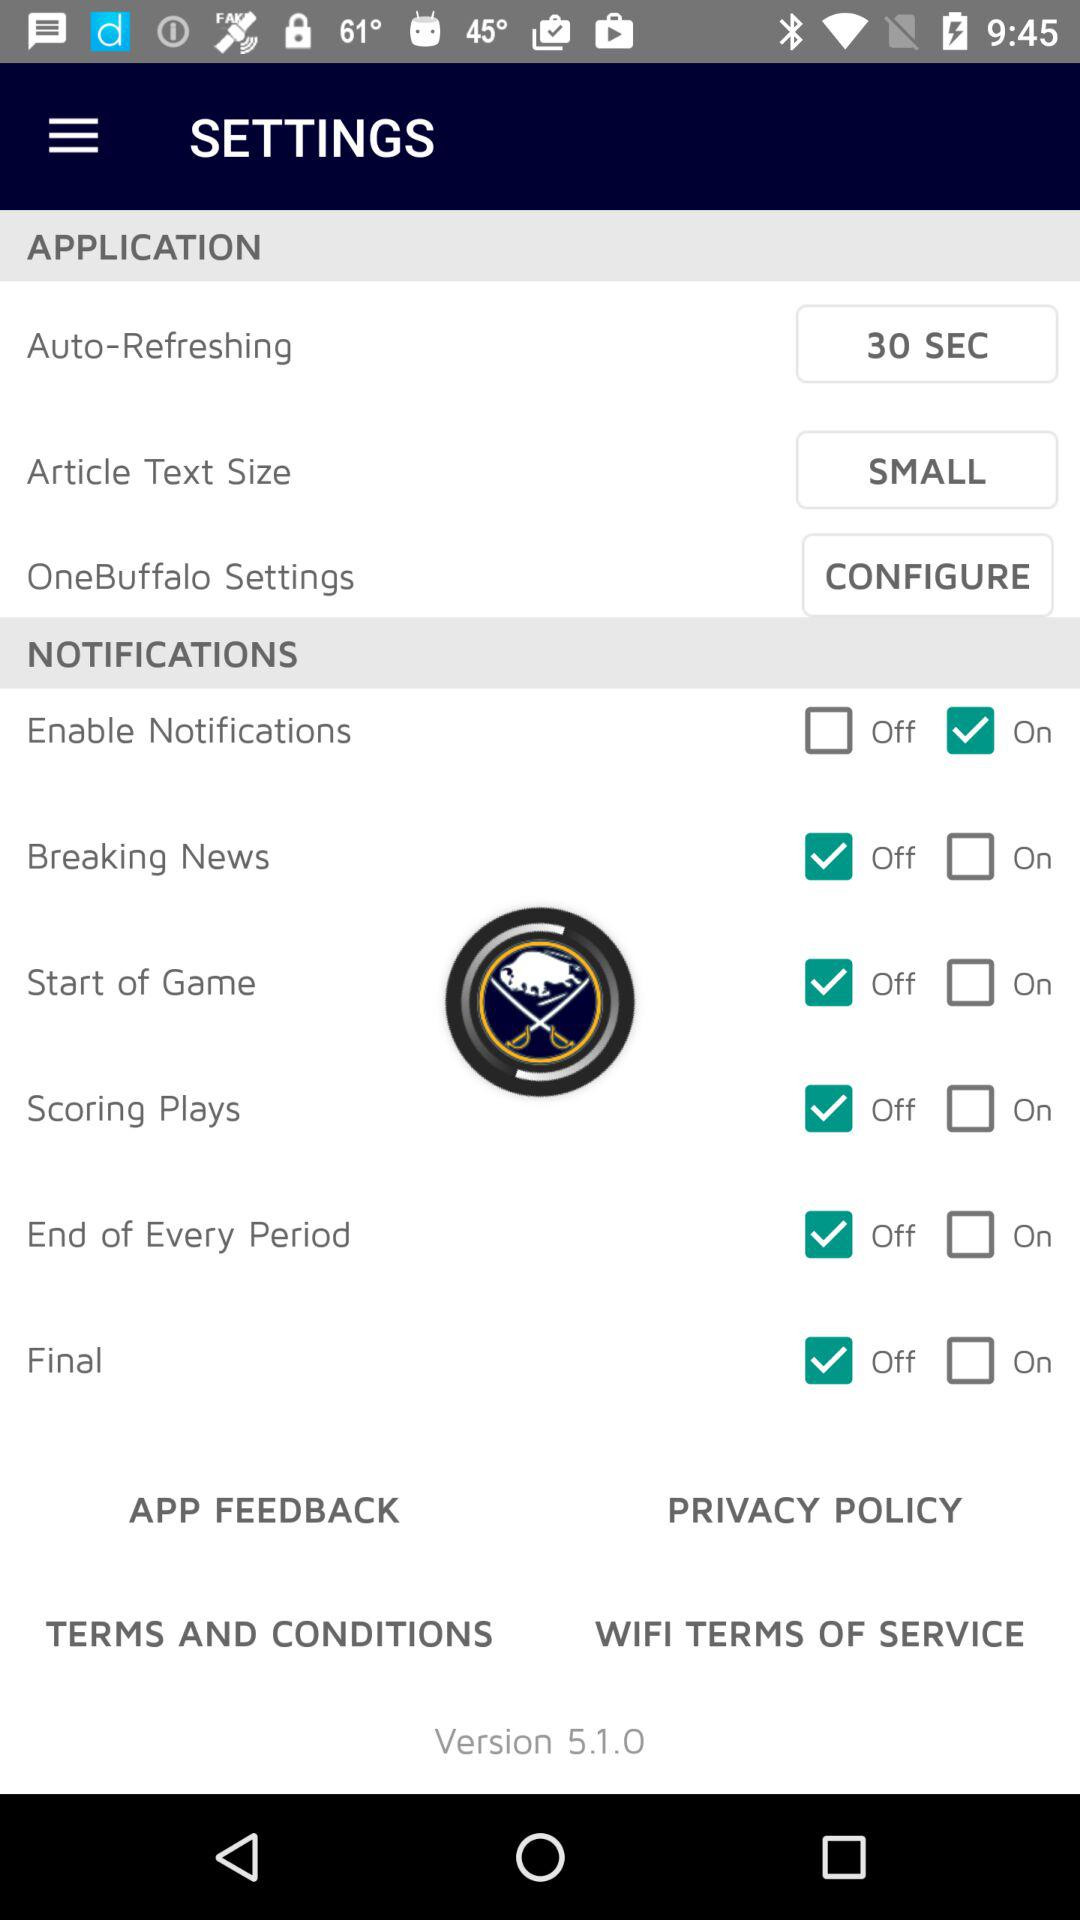Who is this application powered by?
When the provided information is insufficient, respond with <no answer>. <no answer> 